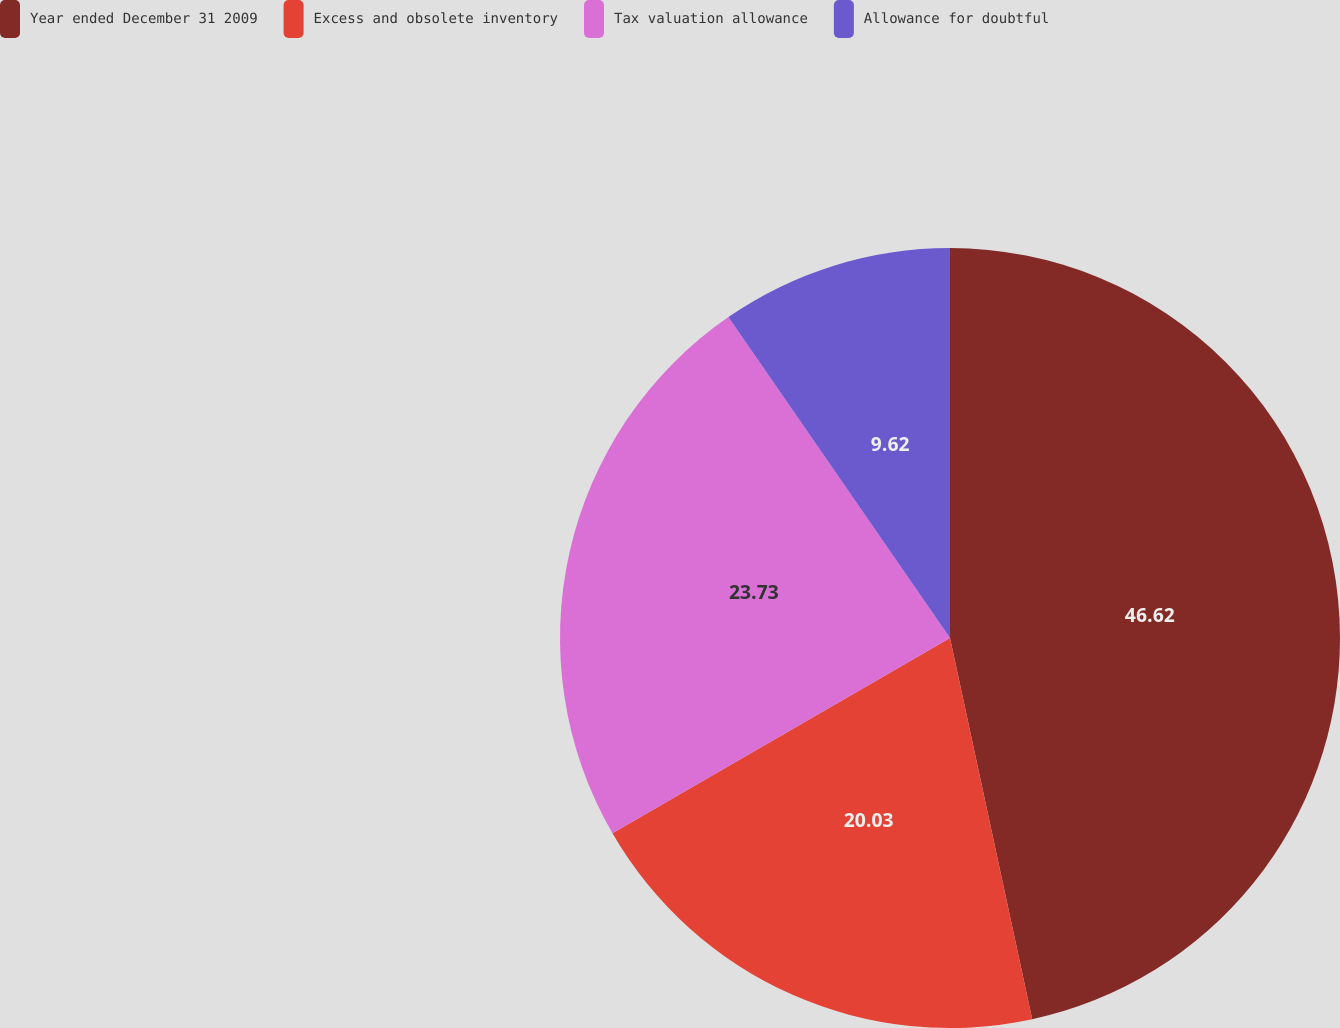Convert chart to OTSL. <chart><loc_0><loc_0><loc_500><loc_500><pie_chart><fcel>Year ended December 31 2009<fcel>Excess and obsolete inventory<fcel>Tax valuation allowance<fcel>Allowance for doubtful<nl><fcel>46.62%<fcel>20.03%<fcel>23.73%<fcel>9.62%<nl></chart> 